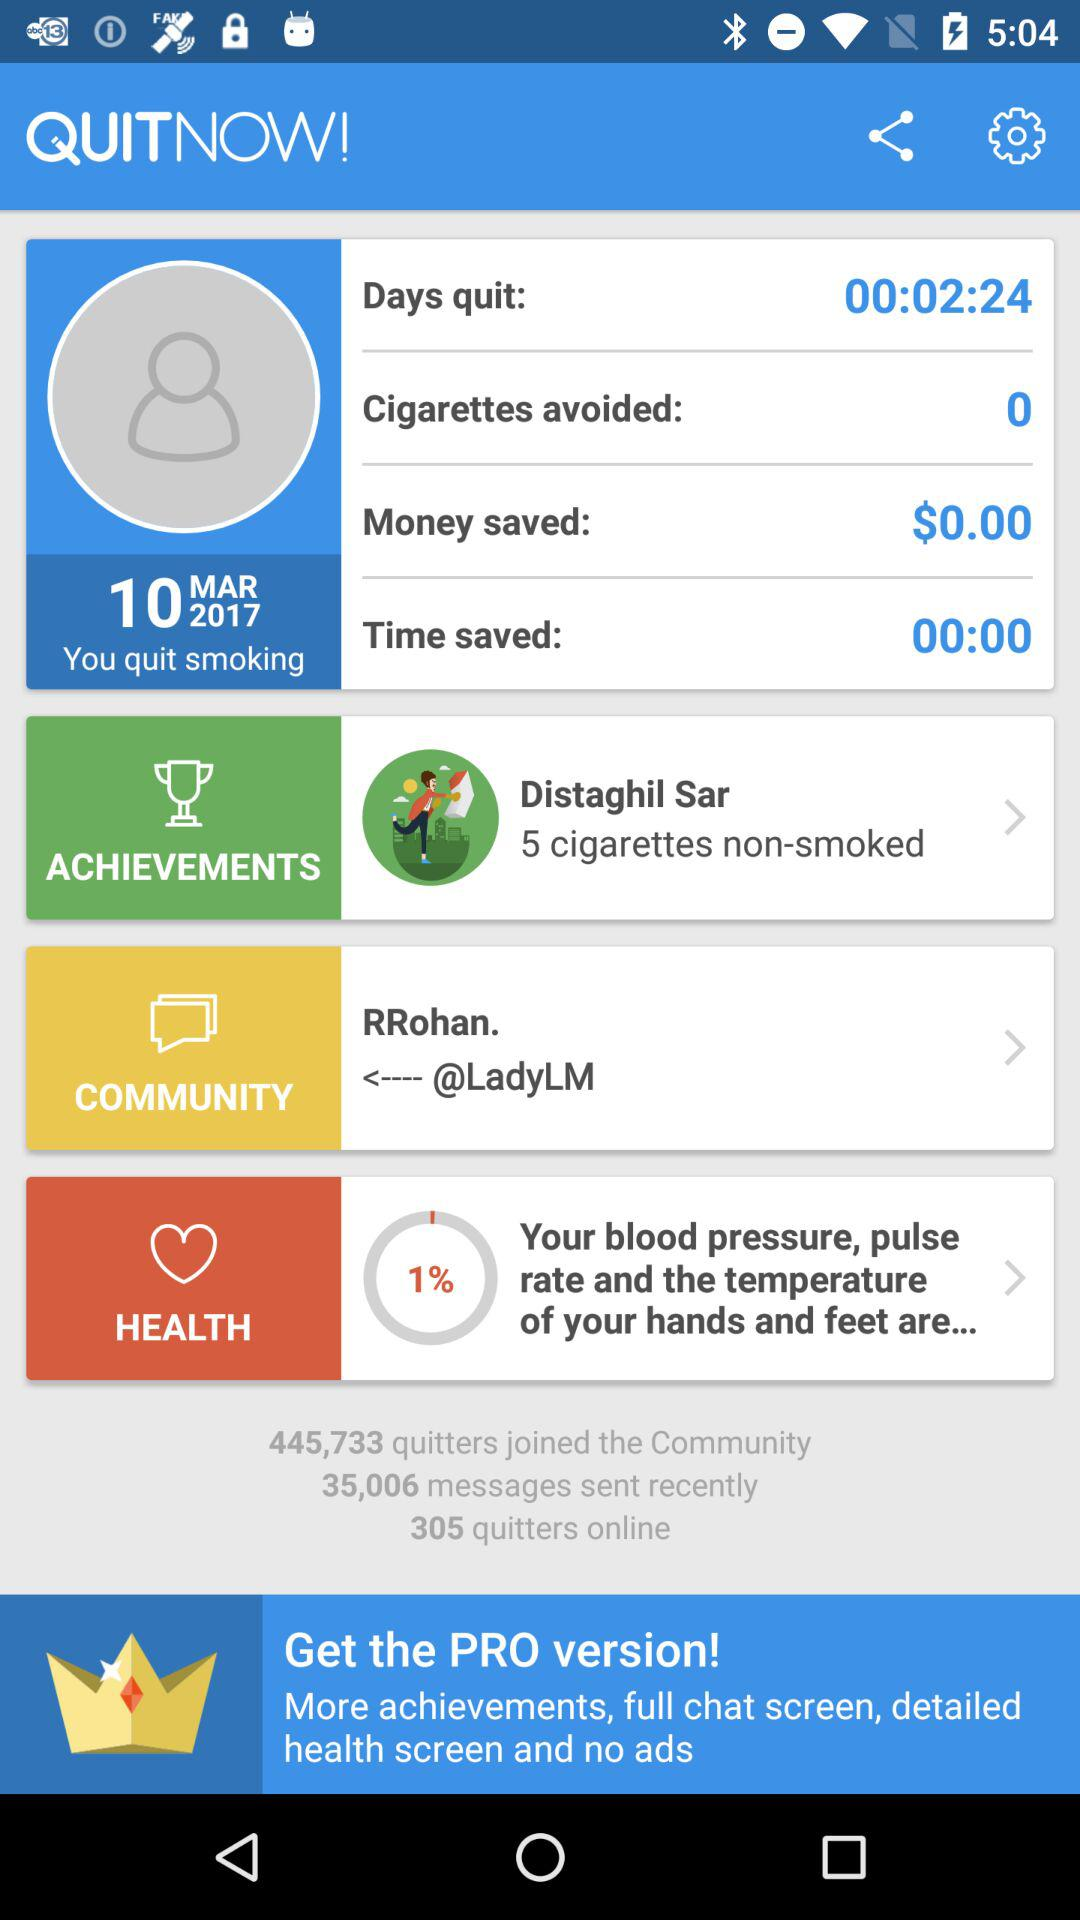What's the total number of quitters who joined the community? The total number of quitters is 445,733. 